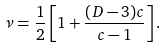<formula> <loc_0><loc_0><loc_500><loc_500>\nu = \frac { 1 } { 2 } \left [ 1 + \frac { ( D - 3 ) c } { c - 1 } \right ] .</formula> 